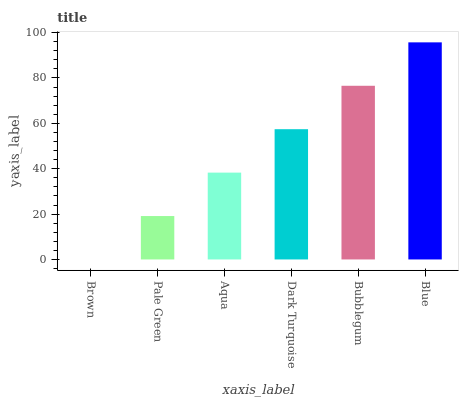Is Brown the minimum?
Answer yes or no. Yes. Is Blue the maximum?
Answer yes or no. Yes. Is Pale Green the minimum?
Answer yes or no. No. Is Pale Green the maximum?
Answer yes or no. No. Is Pale Green greater than Brown?
Answer yes or no. Yes. Is Brown less than Pale Green?
Answer yes or no. Yes. Is Brown greater than Pale Green?
Answer yes or no. No. Is Pale Green less than Brown?
Answer yes or no. No. Is Dark Turquoise the high median?
Answer yes or no. Yes. Is Aqua the low median?
Answer yes or no. Yes. Is Pale Green the high median?
Answer yes or no. No. Is Brown the low median?
Answer yes or no. No. 